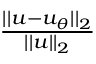<formula> <loc_0><loc_0><loc_500><loc_500>\begin{array} { r } { \frac { | | u - u _ { \theta } | | _ { 2 } } { | | u | | _ { 2 } } } \end{array}</formula> 